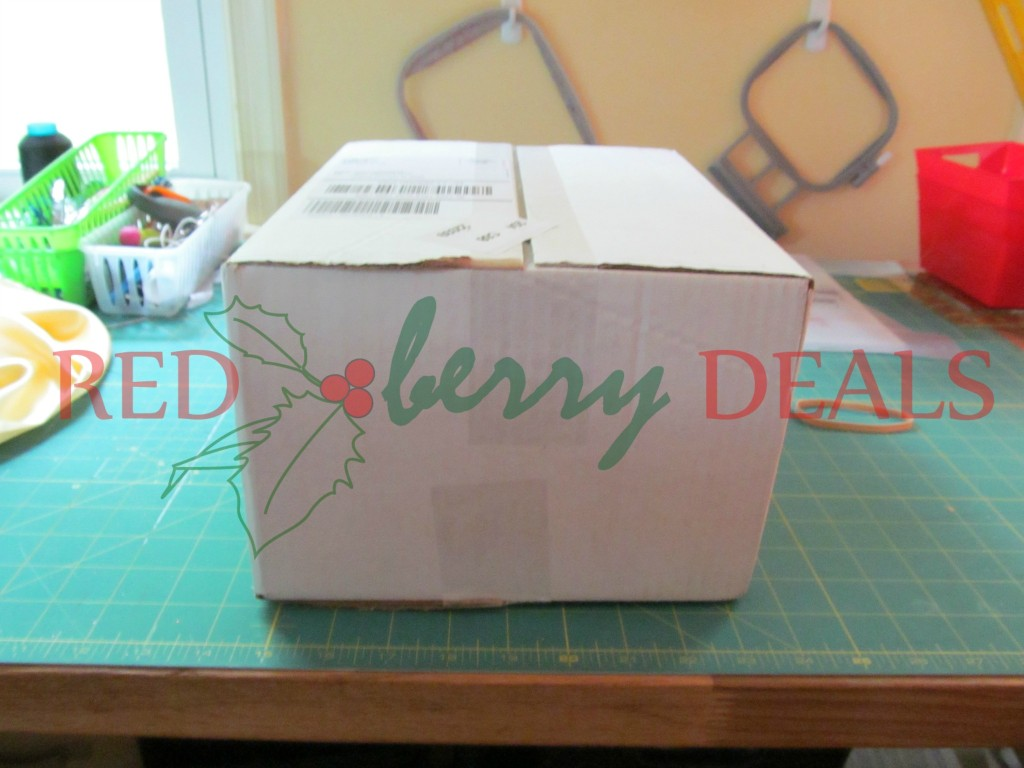Is there any indication of the box being used for shipping or storage based on any visible labels or markings? The box indeed shows signs of being used for shipping. On the top side of the box, there is a visible shipping label that includes a barcode and likely other shipping related details such as addresses and tracking numbers. This label suggests that the box was utilized to transport items, possibly related to the 'RED berry DEALS' branding on the box. Additionally, the box appears to be partially open, hinting at its use in delivering and unpacking goods. 